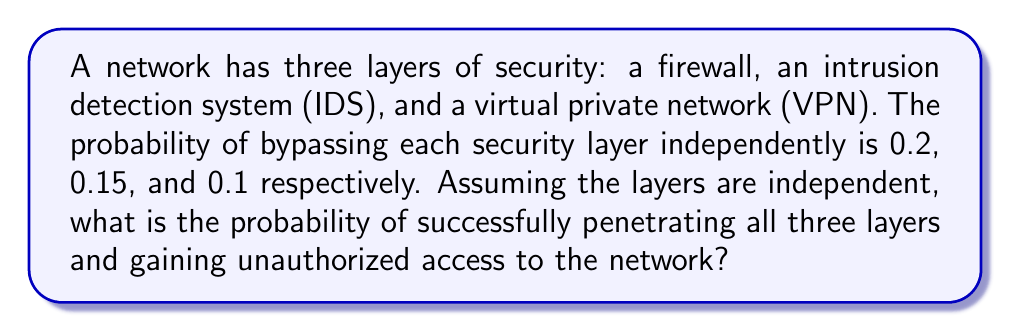Can you solve this math problem? To solve this problem, we need to follow these steps:

1. Identify the given probabilities:
   - Probability of bypassing firewall: $P(F) = 0.2$
   - Probability of bypassing IDS: $P(I) = 0.15$
   - Probability of bypassing VPN: $P(V) = 0.1$

2. Recognize that we need to calculate the probability of all three events occurring simultaneously.

3. Since the layers are independent, we can use the multiplication rule of probability:
   $$P(\text{All layers bypassed}) = P(F) \times P(I) \times P(V)$$

4. Substitute the given probabilities:
   $$P(\text{All layers bypassed}) = 0.2 \times 0.15 \times 0.1$$

5. Perform the multiplication:
   $$P(\text{All layers bypassed}) = 0.003$$

6. Convert to percentage (optional):
   $$P(\text{All layers bypassed}) = 0.003 \times 100\% = 0.3\%$$

Therefore, the probability of successfully penetrating all three layers and gaining unauthorized access to the network is 0.003 or 0.3%.
Answer: 0.003 